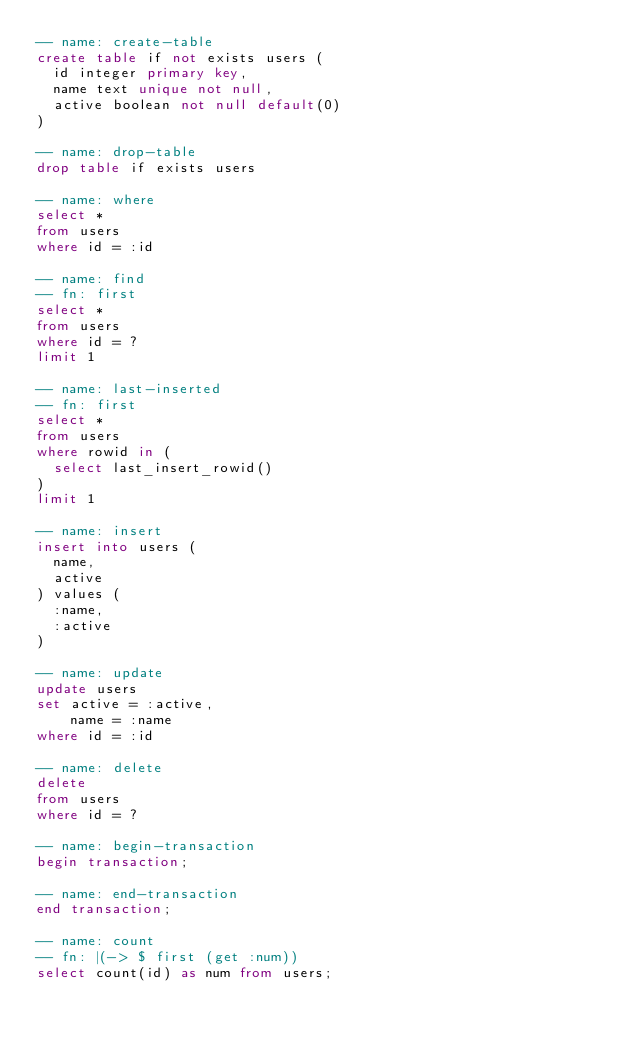Convert code to text. <code><loc_0><loc_0><loc_500><loc_500><_SQL_>-- name: create-table
create table if not exists users (
  id integer primary key,
  name text unique not null,
  active boolean not null default(0)
)

-- name: drop-table
drop table if exists users

-- name: where
select *
from users
where id = :id

-- name: find
-- fn: first
select *
from users
where id = ?
limit 1

-- name: last-inserted
-- fn: first
select *
from users
where rowid in (
  select last_insert_rowid()
)
limit 1

-- name: insert
insert into users (
  name,
  active
) values (
  :name,
  :active
)

-- name: update
update users
set active = :active,
    name = :name
where id = :id

-- name: delete
delete
from users
where id = ?

-- name: begin-transaction
begin transaction;

-- name: end-transaction
end transaction;

-- name: count
-- fn: |(-> $ first (get :num))
select count(id) as num from users;
</code> 